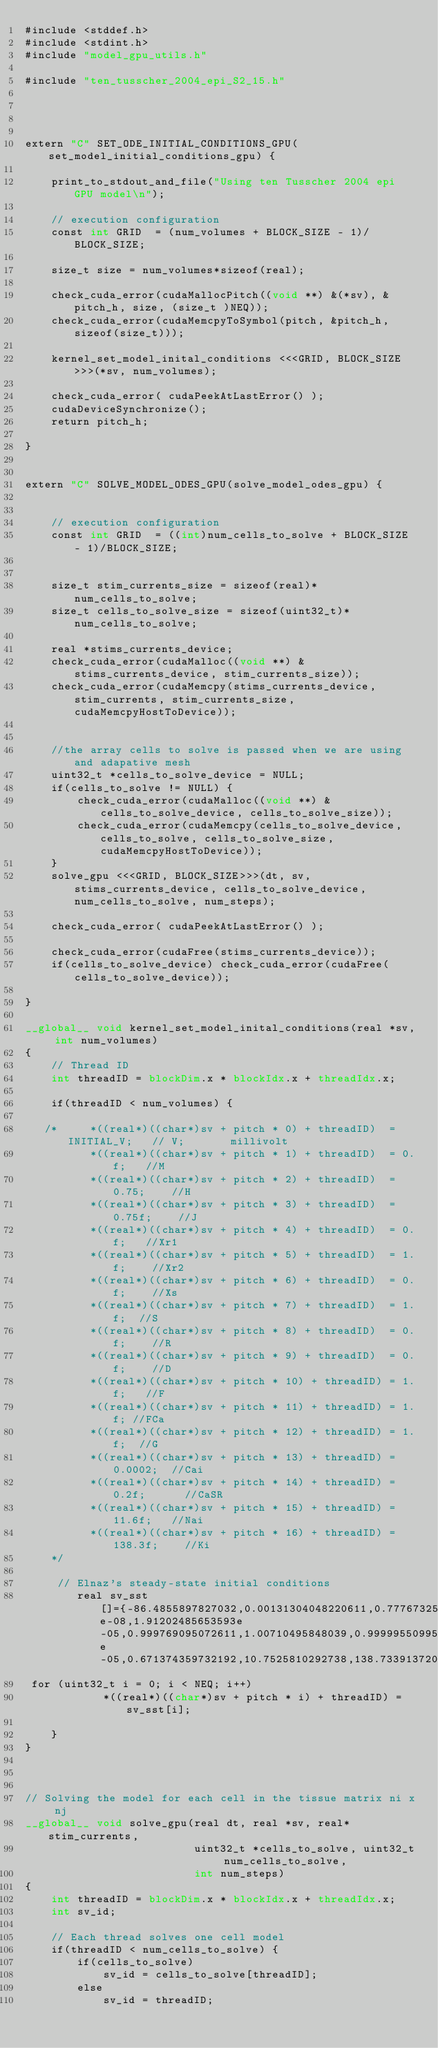<code> <loc_0><loc_0><loc_500><loc_500><_Cuda_>#include <stddef.h>
#include <stdint.h>
#include "model_gpu_utils.h"

#include "ten_tusscher_2004_epi_S2_15.h"




extern "C" SET_ODE_INITIAL_CONDITIONS_GPU(set_model_initial_conditions_gpu) {

    print_to_stdout_and_file("Using ten Tusscher 2004 epi GPU model\n");

    // execution configuration
    const int GRID  = (num_volumes + BLOCK_SIZE - 1)/BLOCK_SIZE;

    size_t size = num_volumes*sizeof(real);

    check_cuda_error(cudaMallocPitch((void **) &(*sv), &pitch_h, size, (size_t )NEQ));
    check_cuda_error(cudaMemcpyToSymbol(pitch, &pitch_h, sizeof(size_t)));

    kernel_set_model_inital_conditions <<<GRID, BLOCK_SIZE>>>(*sv, num_volumes);

    check_cuda_error( cudaPeekAtLastError() );
    cudaDeviceSynchronize();
    return pitch_h;

}


extern "C" SOLVE_MODEL_ODES_GPU(solve_model_odes_gpu) {


    // execution configuration
    const int GRID  = ((int)num_cells_to_solve + BLOCK_SIZE - 1)/BLOCK_SIZE;


    size_t stim_currents_size = sizeof(real)*num_cells_to_solve;
    size_t cells_to_solve_size = sizeof(uint32_t)*num_cells_to_solve;

    real *stims_currents_device;
    check_cuda_error(cudaMalloc((void **) &stims_currents_device, stim_currents_size));
    check_cuda_error(cudaMemcpy(stims_currents_device, stim_currents, stim_currents_size, cudaMemcpyHostToDevice));


    //the array cells to solve is passed when we are using and adapative mesh
    uint32_t *cells_to_solve_device = NULL;
    if(cells_to_solve != NULL) {
        check_cuda_error(cudaMalloc((void **) &cells_to_solve_device, cells_to_solve_size));
        check_cuda_error(cudaMemcpy(cells_to_solve_device, cells_to_solve, cells_to_solve_size, cudaMemcpyHostToDevice));
    }
    solve_gpu <<<GRID, BLOCK_SIZE>>>(dt, sv, stims_currents_device, cells_to_solve_device, num_cells_to_solve, num_steps);

    check_cuda_error( cudaPeekAtLastError() );

    check_cuda_error(cudaFree(stims_currents_device));
    if(cells_to_solve_device) check_cuda_error(cudaFree(cells_to_solve_device));

}

__global__ void kernel_set_model_inital_conditions(real *sv, int num_volumes)
{
    // Thread ID
    int threadID = blockDim.x * blockIdx.x + threadIdx.x;

    if(threadID < num_volumes) {

   /*     *((real*)((char*)sv + pitch * 0) + threadID)  = INITIAL_V;   // V;       millivolt
          *((real*)((char*)sv + pitch * 1) + threadID)  = 0.f;   //M
          *((real*)((char*)sv + pitch * 2) + threadID)  = 0.75;    //H
          *((real*)((char*)sv + pitch * 3) + threadID)  = 0.75f;    //J
          *((real*)((char*)sv + pitch * 4) + threadID)  = 0.f;   //Xr1
          *((real*)((char*)sv + pitch * 5) + threadID)  = 1.f;    //Xr2
          *((real*)((char*)sv + pitch * 6) + threadID)  = 0.f;    //Xs
          *((real*)((char*)sv + pitch * 7) + threadID)  = 1.f;  //S
          *((real*)((char*)sv + pitch * 8) + threadID)  = 0.f;    //R
          *((real*)((char*)sv + pitch * 9) + threadID)  = 0.f;    //D
          *((real*)((char*)sv + pitch * 10) + threadID) = 1.f;   //F
          *((real*)((char*)sv + pitch * 11) + threadID) = 1.f; //FCa
          *((real*)((char*)sv + pitch * 12) + threadID) = 1.f;  //G
          *((real*)((char*)sv + pitch * 13) + threadID) = 0.0002;  //Cai
          *((real*)((char*)sv + pitch * 14) + threadID) = 0.2f;      //CaSR
          *((real*)((char*)sv + pitch * 15) + threadID) = 11.6f;   //Nai
          *((real*)((char*)sv + pitch * 16) + threadID) = 138.3f;    //Ki
    */ 

     // Elnaz's steady-state initial conditions
        real sv_sst[]={-86.4855897827032,0.00131304048220611,0.777673256476332,0.777530419758781,0.000176915007944578,0.484229873407731,0.00295766051225702,0.999998320538839,1.96031195718503e-08,1.91202485653593e-05,0.999769095072611,1.00710495848039,0.999995509954569,4.49502542744173e-05,0.671374359732192,10.7525810292738,138.733913720923};
 for (uint32_t i = 0; i < NEQ; i++)
            *((real*)((char*)sv + pitch * i) + threadID) = sv_sst[i];

    }
}



// Solving the model for each cell in the tissue matrix ni x nj
__global__ void solve_gpu(real dt, real *sv, real* stim_currents,
                          uint32_t *cells_to_solve, uint32_t num_cells_to_solve,
                          int num_steps)
{
    int threadID = blockDim.x * blockIdx.x + threadIdx.x;
    int sv_id;

    // Each thread solves one cell model
    if(threadID < num_cells_to_solve) {
        if(cells_to_solve)
            sv_id = cells_to_solve[threadID];
        else
            sv_id = threadID;
</code> 